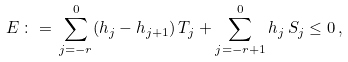<formula> <loc_0><loc_0><loc_500><loc_500>E \, \colon = \, \sum _ { j = - r } ^ { 0 } ( h _ { j } - h _ { j + 1 } ) \, T _ { j } + \sum _ { j = - r + 1 } ^ { 0 } h _ { j } \, S _ { j } \leq 0 \, ,</formula> 